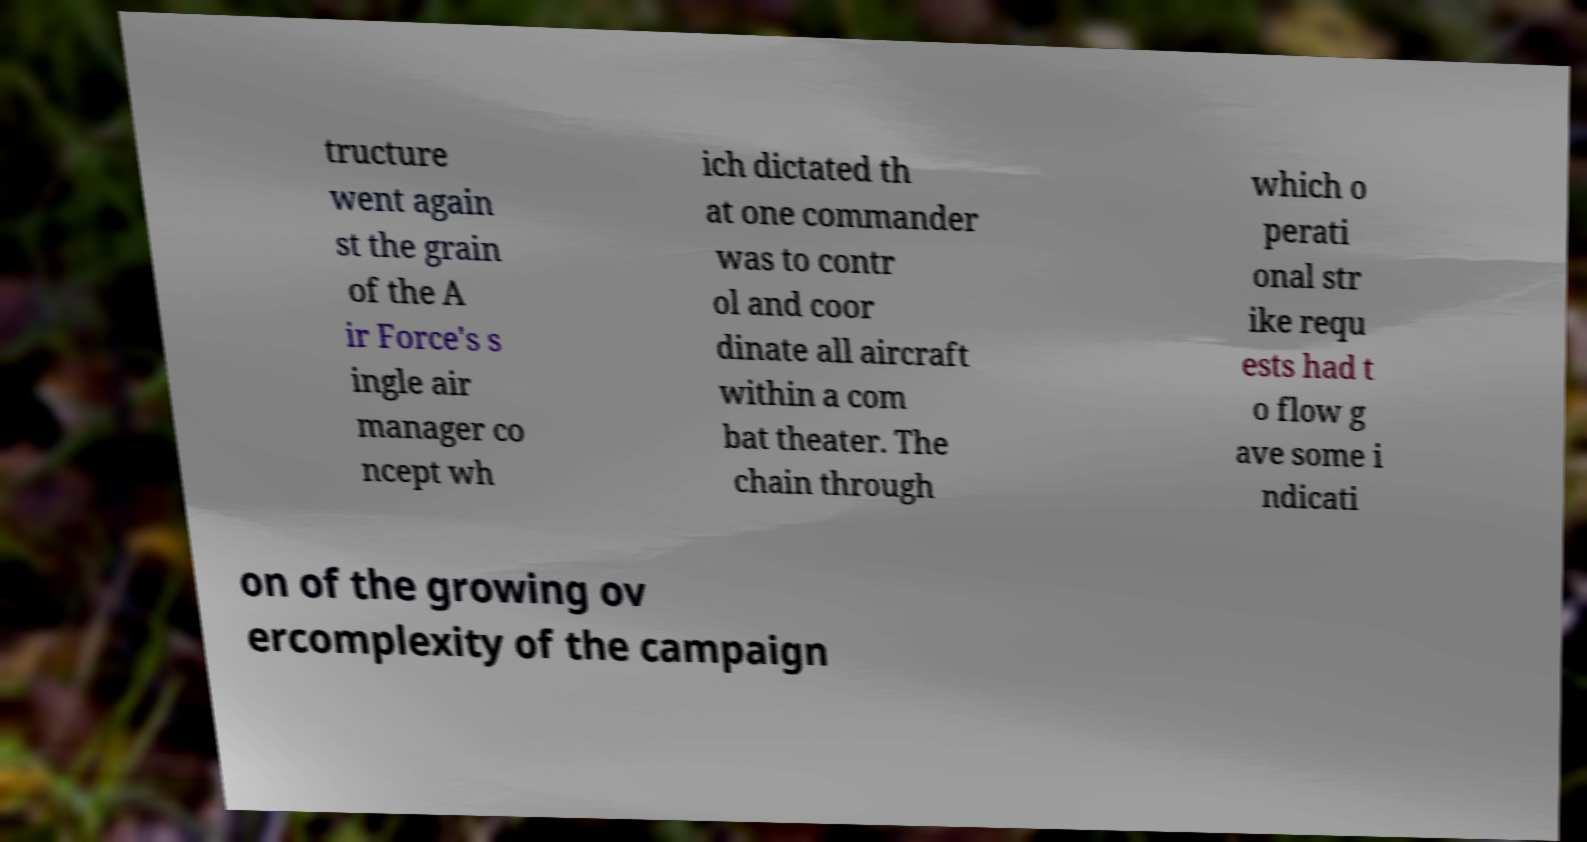I need the written content from this picture converted into text. Can you do that? tructure went again st the grain of the A ir Force's s ingle air manager co ncept wh ich dictated th at one commander was to contr ol and coor dinate all aircraft within a com bat theater. The chain through which o perati onal str ike requ ests had t o flow g ave some i ndicati on of the growing ov ercomplexity of the campaign 